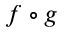Convert formula to latex. <formula><loc_0><loc_0><loc_500><loc_500>f \circ g</formula> 